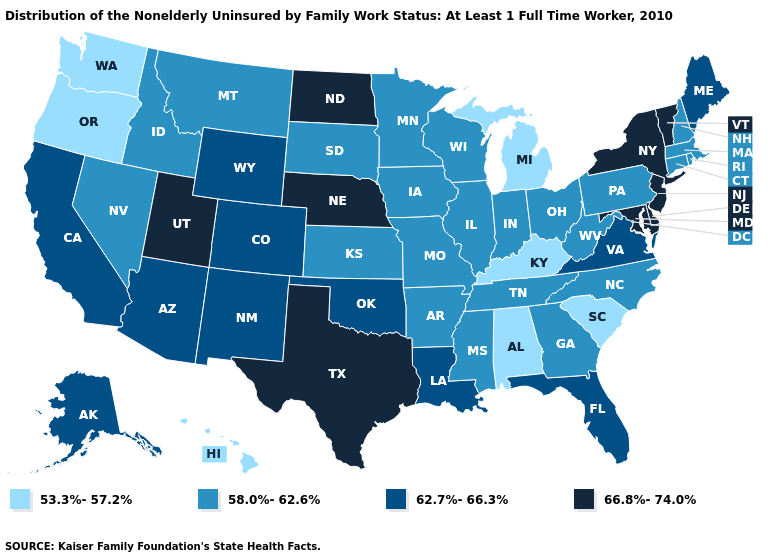Is the legend a continuous bar?
Quick response, please. No. Name the states that have a value in the range 58.0%-62.6%?
Keep it brief. Arkansas, Connecticut, Georgia, Idaho, Illinois, Indiana, Iowa, Kansas, Massachusetts, Minnesota, Mississippi, Missouri, Montana, Nevada, New Hampshire, North Carolina, Ohio, Pennsylvania, Rhode Island, South Dakota, Tennessee, West Virginia, Wisconsin. Does Louisiana have the same value as Virginia?
Concise answer only. Yes. Among the states that border New Jersey , which have the lowest value?
Quick response, please. Pennsylvania. Does the first symbol in the legend represent the smallest category?
Give a very brief answer. Yes. Which states have the lowest value in the USA?
Short answer required. Alabama, Hawaii, Kentucky, Michigan, Oregon, South Carolina, Washington. Which states have the lowest value in the Northeast?
Answer briefly. Connecticut, Massachusetts, New Hampshire, Pennsylvania, Rhode Island. What is the value of New Hampshire?
Give a very brief answer. 58.0%-62.6%. What is the value of Minnesota?
Be succinct. 58.0%-62.6%. Name the states that have a value in the range 66.8%-74.0%?
Give a very brief answer. Delaware, Maryland, Nebraska, New Jersey, New York, North Dakota, Texas, Utah, Vermont. Name the states that have a value in the range 66.8%-74.0%?
Write a very short answer. Delaware, Maryland, Nebraska, New Jersey, New York, North Dakota, Texas, Utah, Vermont. Does the first symbol in the legend represent the smallest category?
Give a very brief answer. Yes. What is the value of Oklahoma?
Give a very brief answer. 62.7%-66.3%. Among the states that border New Mexico , which have the highest value?
Concise answer only. Texas, Utah. 